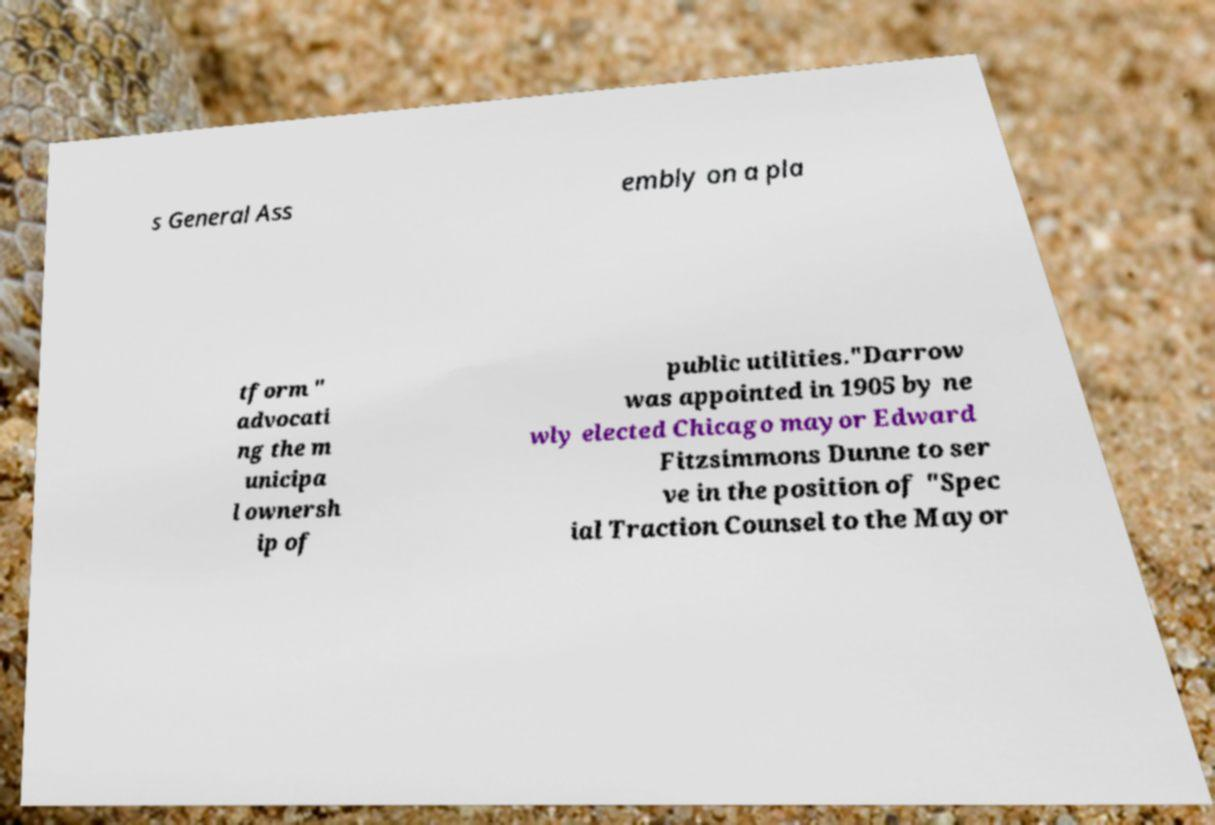Could you extract and type out the text from this image? s General Ass embly on a pla tform " advocati ng the m unicipa l ownersh ip of public utilities."Darrow was appointed in 1905 by ne wly elected Chicago mayor Edward Fitzsimmons Dunne to ser ve in the position of "Spec ial Traction Counsel to the Mayor 